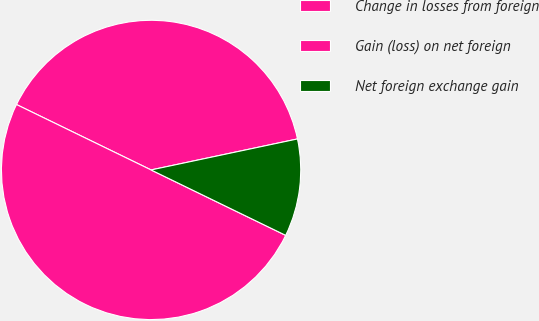Convert chart to OTSL. <chart><loc_0><loc_0><loc_500><loc_500><pie_chart><fcel>Change in losses from foreign<fcel>Gain (loss) on net foreign<fcel>Net foreign exchange gain<nl><fcel>39.48%<fcel>50.0%<fcel>10.52%<nl></chart> 